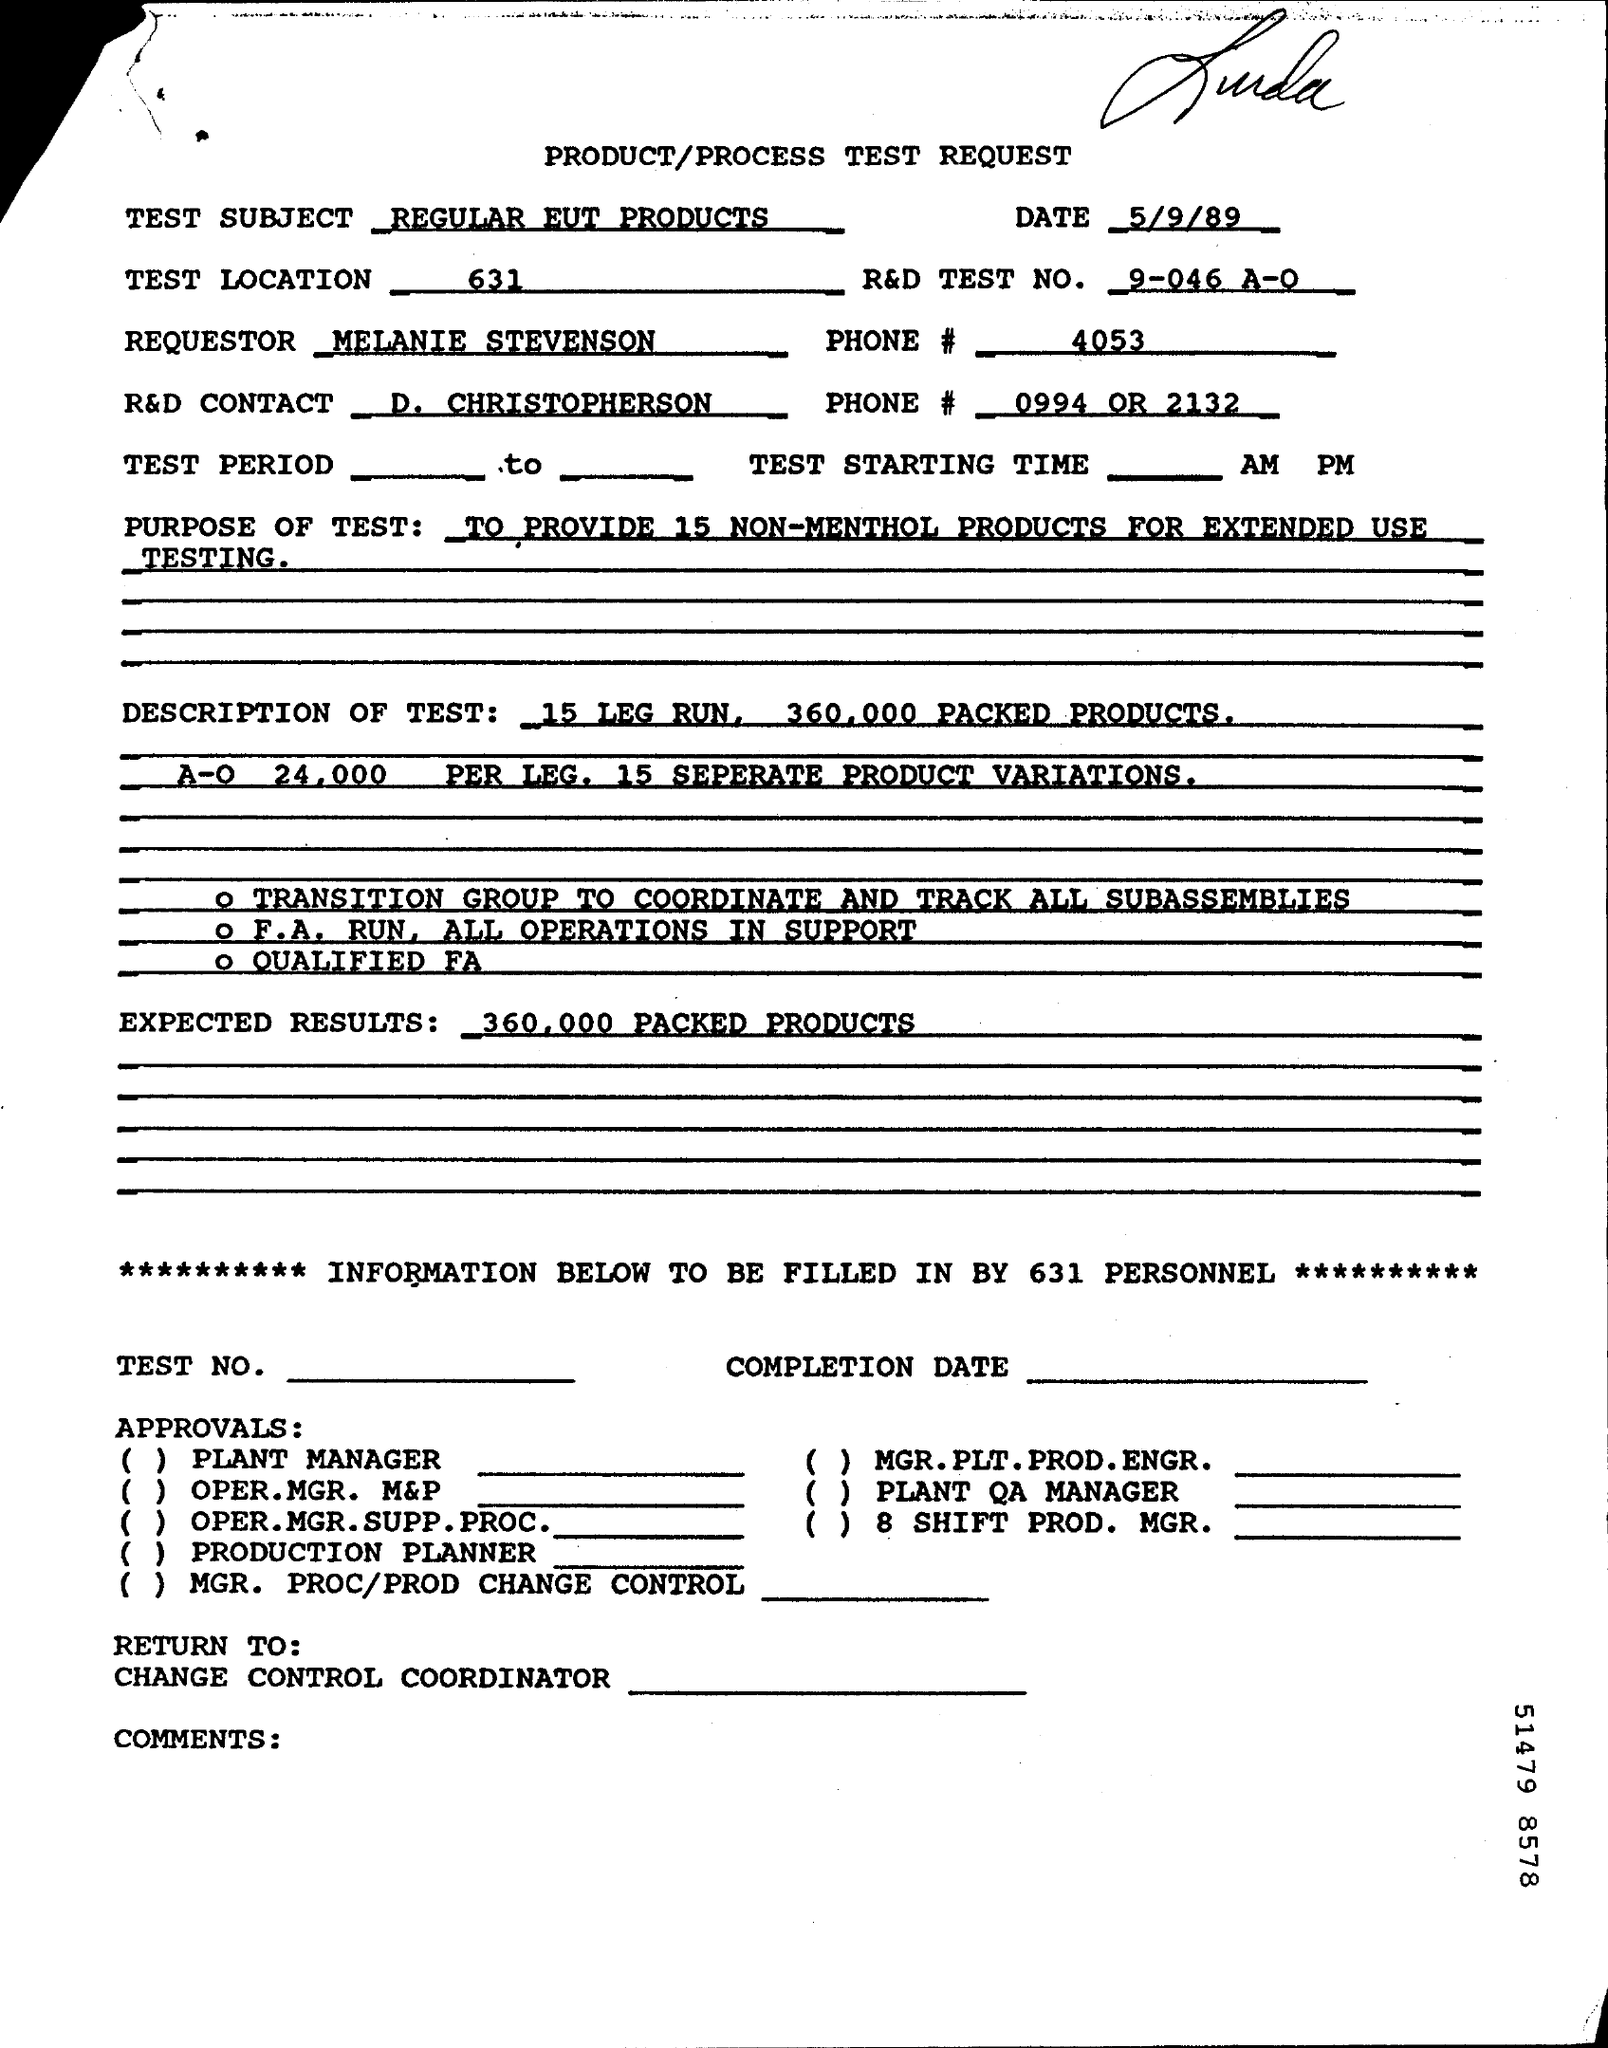Highlight a few significant elements in this photo. It is expected that a total of 360,000 packed products will be produced. The test location number is 631. I would like to inquire about the phone number of the requester, specifically 4053... 